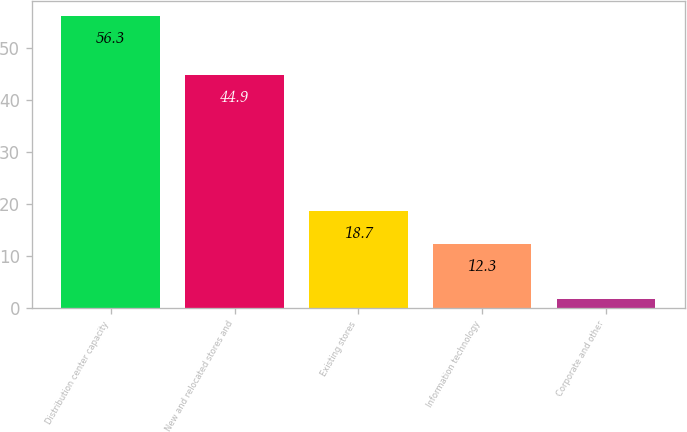Convert chart to OTSL. <chart><loc_0><loc_0><loc_500><loc_500><bar_chart><fcel>Distribution center capacity<fcel>New and relocated stores and<fcel>Existing stores<fcel>Information technology<fcel>Corporate and other<nl><fcel>56.3<fcel>44.9<fcel>18.7<fcel>12.3<fcel>1.8<nl></chart> 